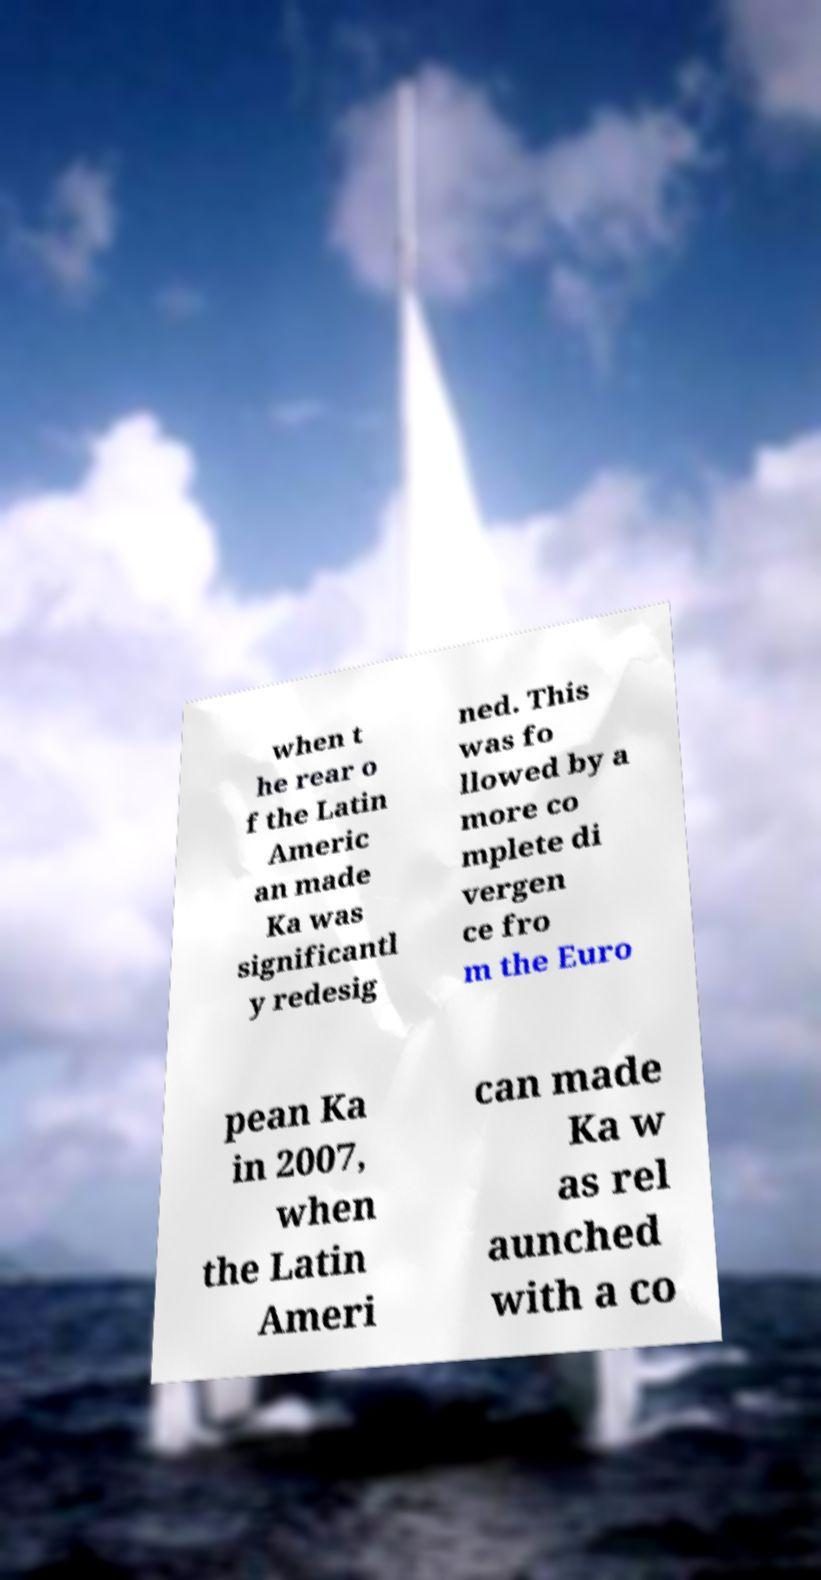Please identify and transcribe the text found in this image. when t he rear o f the Latin Americ an made Ka was significantl y redesig ned. This was fo llowed by a more co mplete di vergen ce fro m the Euro pean Ka in 2007, when the Latin Ameri can made Ka w as rel aunched with a co 